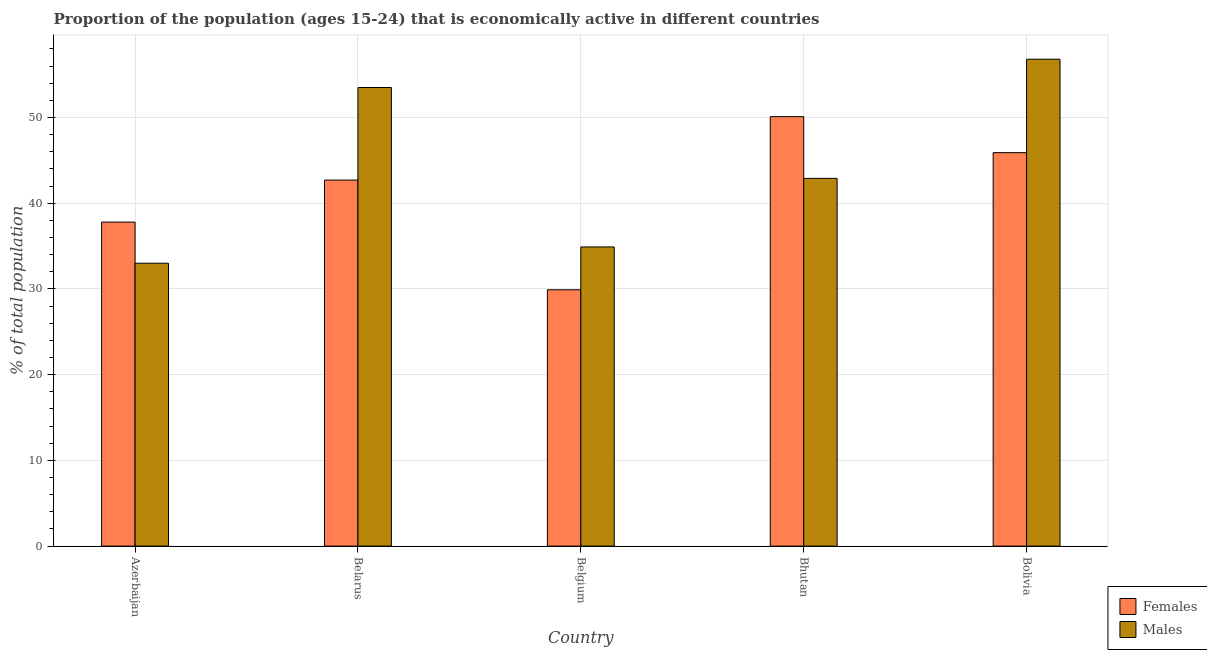How many different coloured bars are there?
Your answer should be very brief. 2. Are the number of bars on each tick of the X-axis equal?
Your response must be concise. Yes. How many bars are there on the 4th tick from the left?
Provide a short and direct response. 2. What is the label of the 3rd group of bars from the left?
Offer a very short reply. Belgium. What is the percentage of economically active female population in Bolivia?
Keep it short and to the point. 45.9. Across all countries, what is the maximum percentage of economically active female population?
Give a very brief answer. 50.1. Across all countries, what is the minimum percentage of economically active male population?
Your response must be concise. 33. In which country was the percentage of economically active male population maximum?
Ensure brevity in your answer.  Bolivia. In which country was the percentage of economically active female population minimum?
Make the answer very short. Belgium. What is the total percentage of economically active male population in the graph?
Make the answer very short. 221.1. What is the difference between the percentage of economically active male population in Belarus and that in Bhutan?
Provide a succinct answer. 10.6. What is the average percentage of economically active male population per country?
Provide a short and direct response. 44.22. What is the difference between the percentage of economically active female population and percentage of economically active male population in Bolivia?
Your answer should be compact. -10.9. What is the ratio of the percentage of economically active female population in Azerbaijan to that in Bhutan?
Keep it short and to the point. 0.75. Is the percentage of economically active male population in Azerbaijan less than that in Bolivia?
Give a very brief answer. Yes. Is the difference between the percentage of economically active male population in Bhutan and Bolivia greater than the difference between the percentage of economically active female population in Bhutan and Bolivia?
Your answer should be compact. No. What is the difference between the highest and the second highest percentage of economically active female population?
Offer a terse response. 4.2. What is the difference between the highest and the lowest percentage of economically active male population?
Offer a very short reply. 23.8. What does the 2nd bar from the left in Bhutan represents?
Provide a succinct answer. Males. What does the 2nd bar from the right in Azerbaijan represents?
Your answer should be compact. Females. How many bars are there?
Offer a very short reply. 10. Are all the bars in the graph horizontal?
Keep it short and to the point. No. Does the graph contain any zero values?
Make the answer very short. No. Does the graph contain grids?
Provide a succinct answer. Yes. Where does the legend appear in the graph?
Give a very brief answer. Bottom right. How many legend labels are there?
Give a very brief answer. 2. What is the title of the graph?
Your answer should be very brief. Proportion of the population (ages 15-24) that is economically active in different countries. Does "Excluding technical cooperation" appear as one of the legend labels in the graph?
Your answer should be very brief. No. What is the label or title of the Y-axis?
Your answer should be compact. % of total population. What is the % of total population in Females in Azerbaijan?
Your answer should be very brief. 37.8. What is the % of total population of Males in Azerbaijan?
Your answer should be compact. 33. What is the % of total population in Females in Belarus?
Keep it short and to the point. 42.7. What is the % of total population in Males in Belarus?
Your answer should be compact. 53.5. What is the % of total population of Females in Belgium?
Ensure brevity in your answer.  29.9. What is the % of total population in Males in Belgium?
Provide a succinct answer. 34.9. What is the % of total population of Females in Bhutan?
Your answer should be very brief. 50.1. What is the % of total population of Males in Bhutan?
Give a very brief answer. 42.9. What is the % of total population in Females in Bolivia?
Your answer should be very brief. 45.9. What is the % of total population of Males in Bolivia?
Give a very brief answer. 56.8. Across all countries, what is the maximum % of total population of Females?
Provide a succinct answer. 50.1. Across all countries, what is the maximum % of total population in Males?
Ensure brevity in your answer.  56.8. Across all countries, what is the minimum % of total population of Females?
Offer a very short reply. 29.9. What is the total % of total population in Females in the graph?
Provide a succinct answer. 206.4. What is the total % of total population in Males in the graph?
Make the answer very short. 221.1. What is the difference between the % of total population in Females in Azerbaijan and that in Belarus?
Your response must be concise. -4.9. What is the difference between the % of total population of Males in Azerbaijan and that in Belarus?
Provide a succinct answer. -20.5. What is the difference between the % of total population in Males in Azerbaijan and that in Belgium?
Your response must be concise. -1.9. What is the difference between the % of total population of Females in Azerbaijan and that in Bhutan?
Provide a succinct answer. -12.3. What is the difference between the % of total population of Males in Azerbaijan and that in Bolivia?
Provide a short and direct response. -23.8. What is the difference between the % of total population of Females in Belgium and that in Bhutan?
Your answer should be very brief. -20.2. What is the difference between the % of total population in Males in Belgium and that in Bolivia?
Keep it short and to the point. -21.9. What is the difference between the % of total population in Females in Bhutan and that in Bolivia?
Your response must be concise. 4.2. What is the difference between the % of total population in Females in Azerbaijan and the % of total population in Males in Belarus?
Keep it short and to the point. -15.7. What is the difference between the % of total population in Females in Belarus and the % of total population in Males in Belgium?
Make the answer very short. 7.8. What is the difference between the % of total population of Females in Belarus and the % of total population of Males in Bhutan?
Offer a very short reply. -0.2. What is the difference between the % of total population of Females in Belarus and the % of total population of Males in Bolivia?
Give a very brief answer. -14.1. What is the difference between the % of total population in Females in Belgium and the % of total population in Males in Bhutan?
Provide a succinct answer. -13. What is the difference between the % of total population of Females in Belgium and the % of total population of Males in Bolivia?
Give a very brief answer. -26.9. What is the difference between the % of total population of Females in Bhutan and the % of total population of Males in Bolivia?
Give a very brief answer. -6.7. What is the average % of total population of Females per country?
Provide a short and direct response. 41.28. What is the average % of total population in Males per country?
Keep it short and to the point. 44.22. What is the difference between the % of total population in Females and % of total population in Males in Azerbaijan?
Offer a very short reply. 4.8. What is the difference between the % of total population in Females and % of total population in Males in Belgium?
Your answer should be very brief. -5. What is the difference between the % of total population of Females and % of total population of Males in Bhutan?
Your response must be concise. 7.2. What is the difference between the % of total population in Females and % of total population in Males in Bolivia?
Ensure brevity in your answer.  -10.9. What is the ratio of the % of total population of Females in Azerbaijan to that in Belarus?
Your response must be concise. 0.89. What is the ratio of the % of total population in Males in Azerbaijan to that in Belarus?
Ensure brevity in your answer.  0.62. What is the ratio of the % of total population in Females in Azerbaijan to that in Belgium?
Keep it short and to the point. 1.26. What is the ratio of the % of total population in Males in Azerbaijan to that in Belgium?
Your answer should be very brief. 0.95. What is the ratio of the % of total population of Females in Azerbaijan to that in Bhutan?
Provide a short and direct response. 0.75. What is the ratio of the % of total population of Males in Azerbaijan to that in Bhutan?
Ensure brevity in your answer.  0.77. What is the ratio of the % of total population of Females in Azerbaijan to that in Bolivia?
Give a very brief answer. 0.82. What is the ratio of the % of total population of Males in Azerbaijan to that in Bolivia?
Provide a short and direct response. 0.58. What is the ratio of the % of total population in Females in Belarus to that in Belgium?
Keep it short and to the point. 1.43. What is the ratio of the % of total population in Males in Belarus to that in Belgium?
Your answer should be compact. 1.53. What is the ratio of the % of total population of Females in Belarus to that in Bhutan?
Ensure brevity in your answer.  0.85. What is the ratio of the % of total population of Males in Belarus to that in Bhutan?
Your answer should be very brief. 1.25. What is the ratio of the % of total population of Females in Belarus to that in Bolivia?
Provide a succinct answer. 0.93. What is the ratio of the % of total population in Males in Belarus to that in Bolivia?
Ensure brevity in your answer.  0.94. What is the ratio of the % of total population of Females in Belgium to that in Bhutan?
Ensure brevity in your answer.  0.6. What is the ratio of the % of total population in Males in Belgium to that in Bhutan?
Your answer should be compact. 0.81. What is the ratio of the % of total population of Females in Belgium to that in Bolivia?
Your answer should be very brief. 0.65. What is the ratio of the % of total population in Males in Belgium to that in Bolivia?
Make the answer very short. 0.61. What is the ratio of the % of total population in Females in Bhutan to that in Bolivia?
Keep it short and to the point. 1.09. What is the ratio of the % of total population in Males in Bhutan to that in Bolivia?
Offer a very short reply. 0.76. What is the difference between the highest and the second highest % of total population in Males?
Your answer should be compact. 3.3. What is the difference between the highest and the lowest % of total population of Females?
Offer a very short reply. 20.2. What is the difference between the highest and the lowest % of total population in Males?
Make the answer very short. 23.8. 